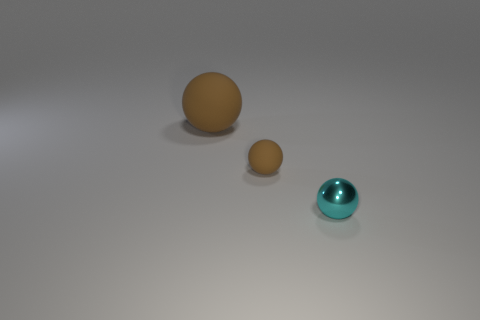Add 2 small brown matte things. How many objects exist? 5 Subtract all small spheres. How many spheres are left? 1 Subtract all cyan spheres. How many spheres are left? 2 Subtract 2 balls. How many balls are left? 1 Subtract all cyan balls. Subtract all red cubes. How many balls are left? 2 Subtract all yellow blocks. How many cyan spheres are left? 1 Subtract all cyan metal spheres. Subtract all large things. How many objects are left? 1 Add 2 brown spheres. How many brown spheres are left? 4 Add 3 yellow rubber cubes. How many yellow rubber cubes exist? 3 Subtract 0 brown cylinders. How many objects are left? 3 